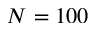Convert formula to latex. <formula><loc_0><loc_0><loc_500><loc_500>N = 1 0 0</formula> 